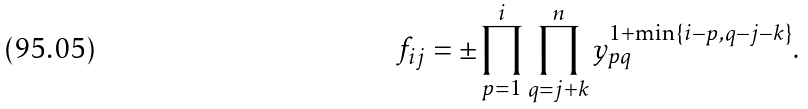<formula> <loc_0><loc_0><loc_500><loc_500>f _ { i j } = \pm \prod _ { p = 1 } ^ { i } \prod _ { q = j + k } ^ { n } y _ { p q } ^ { 1 + \min \{ i - p , q - j - k \} } .</formula> 